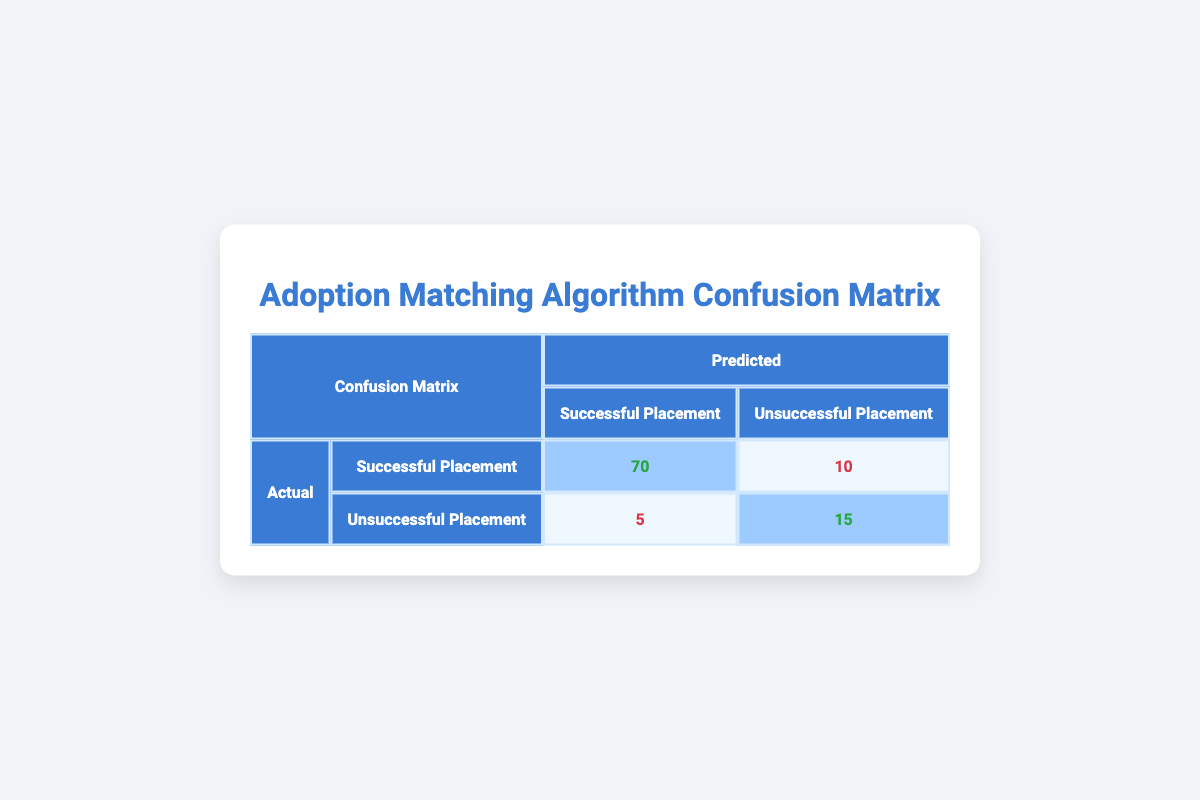What is the count of successful placements that were predicted as successful? The table shows that 70 successful placements were predicted correctly as successful placements. This value is directly available in the matrix under the corresponding cells.
Answer: 70 How many total placements were predicted as unsuccessful? To find this, we look at the total predictions for unsuccessful placements, which includes both actual successful placements predicted as unsuccessful (10) and actual unsuccessful placements predicted correctly as unsuccessful (15). Adding these together, 10 + 15 = 25.
Answer: 25 What is the total number of successful placements? Successful placements are represented by the sum of successful placements that were predicted correctly (70) and those that were predicted incorrectly as unsuccessful (10). Thus the total is 70 + 10 = 80.
Answer: 80 Is the prediction algorithm more accurate for successful placements than for unsuccessful placements? To evaluate accuracy, we can compare the counts for successful placements predicted correctly (70) to unsuccessful placements predicted correctly (15). Since 70 is greater than 15, it indicates that the algorithm is more accurate for successful placements.
Answer: Yes What is the false positive rate for predictions? The false positive rate is calculated by taking the number of unsuccessful placements predicted as successful (5) and dividing it by the total actual unsuccessful placements (5 + 15 = 20). Thus, the false positive rate is 5 / 20 = 0.25 or 25%.
Answer: 25% What is the true positive rate for successful placements? The true positive rate, or sensitivity, is calculated by taking the number of successful placements predicted correctly (70) and dividing it by the total actual successful placements (70 + 10 = 80). Therefore, the true positive rate is 70 / 80 = 0.875 or 87.5%.
Answer: 87.5% How many placements were actually unsuccessful? The total number of actual unsuccessful placements is the sum of those predicted correctly as unsuccessful (15) and those incorrectly predicted as successful (5). Therefore, it is 15 + 5 = 20.
Answer: 20 What is the count of all placements where the predictions were incorrect? The total count of incorrect predictions is the sum of predictions where successful placements were incorrectly identified as unsuccessful (10) and unsuccessful placements identified as successful (5). Thus, the total is 10 + 5 = 15.
Answer: 15 How would you classify the overall performance of the algorithm based on the matrix? Overall performance can be classified based on the true positives, true negatives, false positives, and false negatives. In this case, the true positives (70) are significantly higher than the sum of false positives (10) and false negatives (5), indicating that the algorithm performs well in predicting successful placements while having a reasonable performance in predicting unsuccessful placements.
Answer: Good 